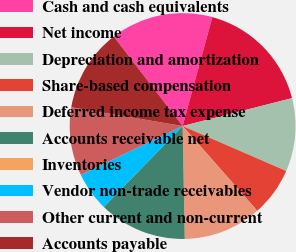<chart> <loc_0><loc_0><loc_500><loc_500><pie_chart><fcel>Cash and cash equivalents<fcel>Net income<fcel>Depreciation and amortization<fcel>Share-based compensation<fcel>Deferred income tax expense<fcel>Accounts receivable net<fcel>Inventories<fcel>Vendor non-trade receivables<fcel>Other current and non-current<fcel>Accounts payable<nl><fcel>14.68%<fcel>16.78%<fcel>10.49%<fcel>6.99%<fcel>11.19%<fcel>12.59%<fcel>0.0%<fcel>5.59%<fcel>9.79%<fcel>11.89%<nl></chart> 